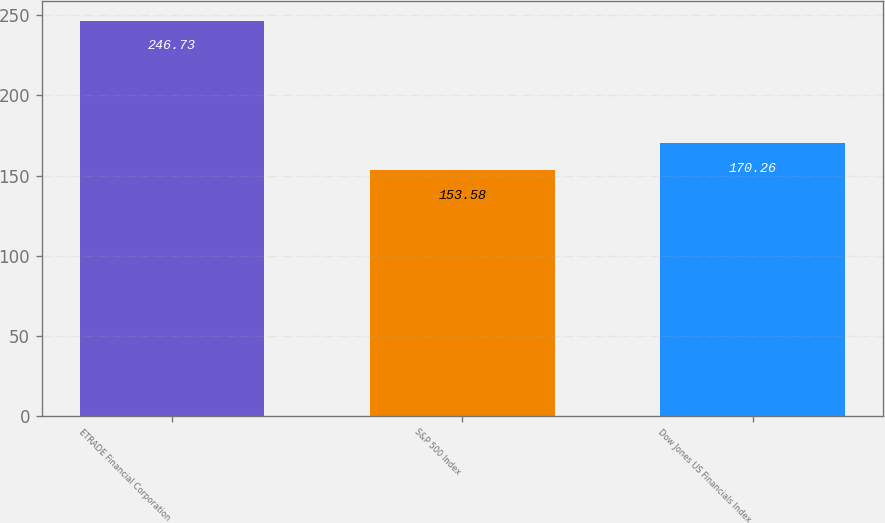Convert chart to OTSL. <chart><loc_0><loc_0><loc_500><loc_500><bar_chart><fcel>ETRADE Financial Corporation<fcel>S&P 500 Index<fcel>Dow Jones US Financials Index<nl><fcel>246.73<fcel>153.58<fcel>170.26<nl></chart> 